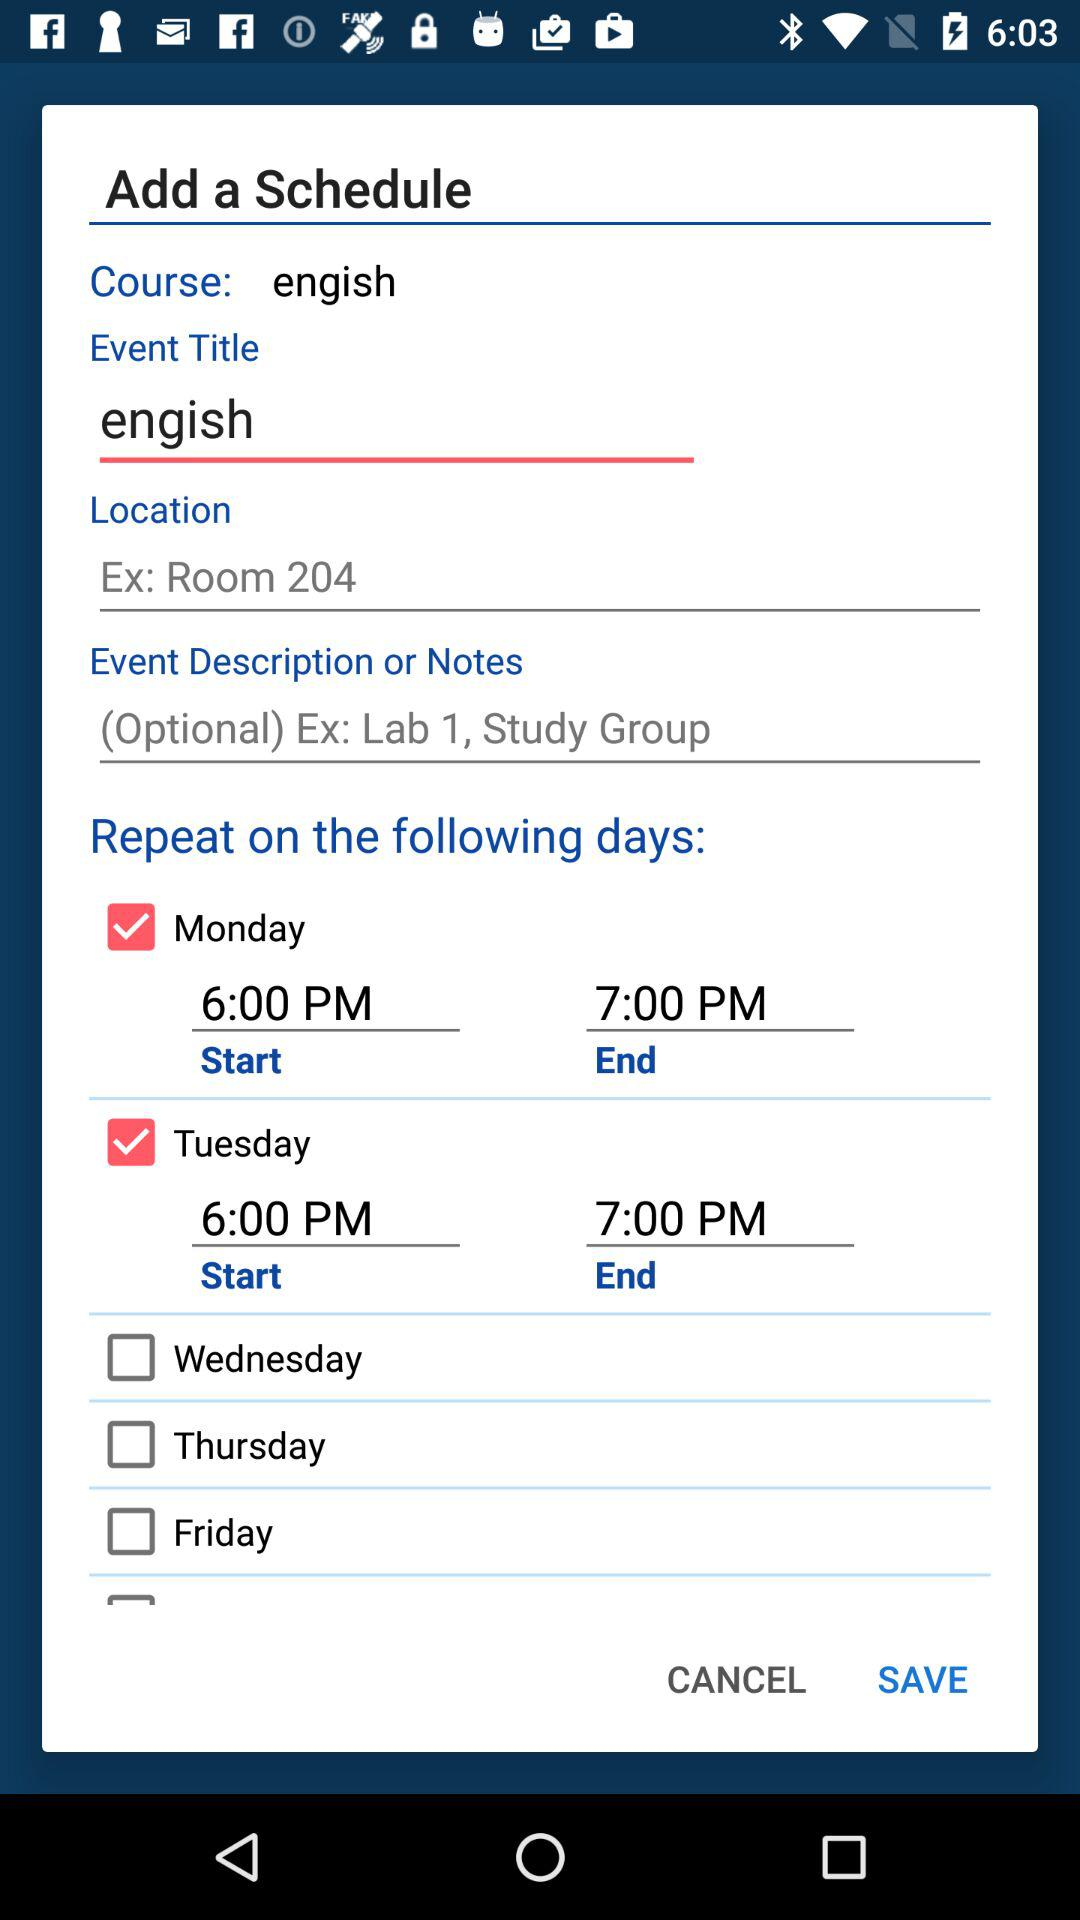When will the class end on Tuesday? The class will end at 7:00 PM. 